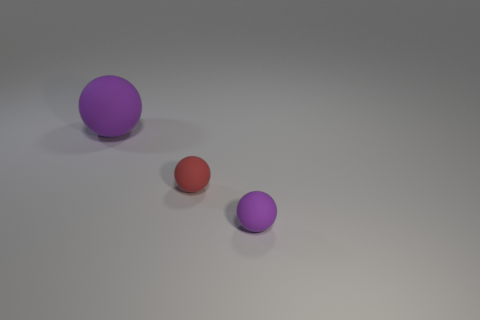How many things are either gray rubber cylinders or purple objects left of the tiny purple thing?
Provide a short and direct response. 1. There is a ball that is to the right of the red object; is its size the same as the tiny red rubber ball?
Your answer should be very brief. Yes. How many other objects are the same size as the red matte object?
Your answer should be very brief. 1. What is the color of the large sphere?
Your response must be concise. Purple. There is a big thing to the left of the tiny red thing; what material is it?
Ensure brevity in your answer.  Rubber. Are there the same number of matte spheres that are in front of the small purple sphere and purple rubber things?
Provide a succinct answer. No. Do the big rubber object and the red matte thing have the same shape?
Make the answer very short. Yes. Is there anything else that is the same color as the large rubber object?
Your response must be concise. Yes. The matte object that is in front of the big rubber ball and to the left of the tiny purple thing has what shape?
Keep it short and to the point. Sphere. Are there the same number of things left of the large purple sphere and tiny rubber spheres that are in front of the small red matte ball?
Your answer should be compact. No. 